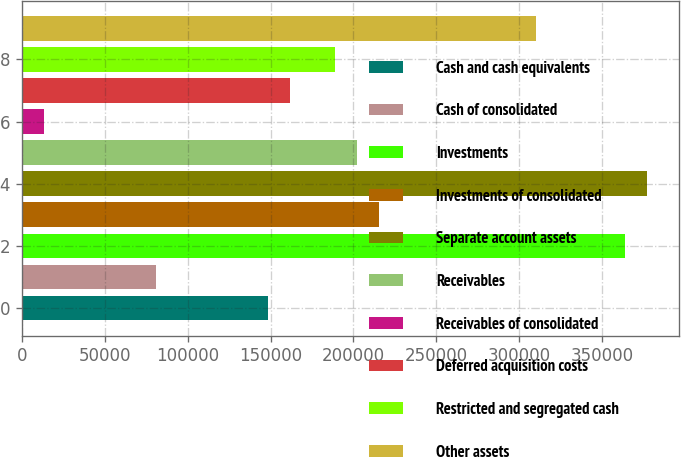<chart> <loc_0><loc_0><loc_500><loc_500><bar_chart><fcel>Cash and cash equivalents<fcel>Cash of consolidated<fcel>Investments<fcel>Investments of consolidated<fcel>Separate account assets<fcel>Receivables<fcel>Receivables of consolidated<fcel>Deferred acquisition costs<fcel>Restricted and segregated cash<fcel>Other assets<nl><fcel>148202<fcel>80838.6<fcel>363763<fcel>215565<fcel>377236<fcel>202092<fcel>13475.6<fcel>161674<fcel>188619<fcel>309873<nl></chart> 